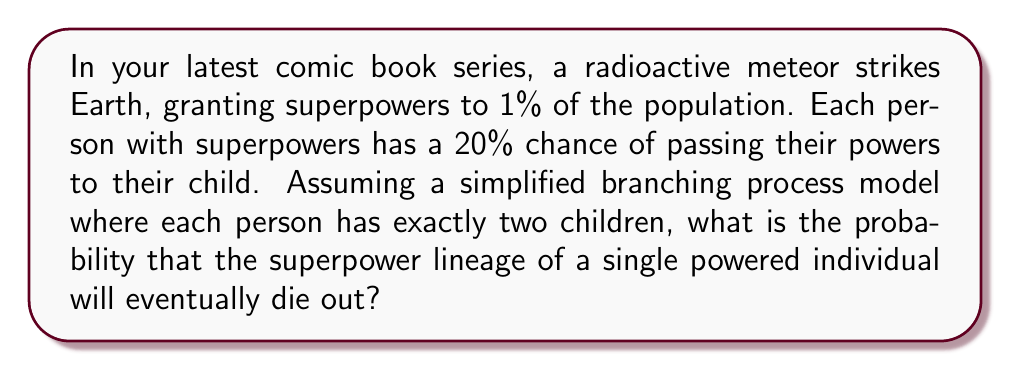Solve this math problem. Let's approach this step-by-step using the theory of branching processes:

1) Let $p_k$ be the probability of a powered individual having $k$ powered children. In this case:
   $p_0 = 0.64$ (probability of neither child inheriting powers)
   $p_1 = 0.32$ (probability of exactly one child inheriting powers)
   $p_2 = 0.04$ (probability of both children inheriting powers)

2) The probability generating function (PGF) for this process is:
   $$G(s) = p_0 + p_1s + p_2s^2 = 0.64 + 0.32s + 0.04s^2$$

3) The extinction probability, $q$, is the smallest non-negative root of the equation $s = G(s)$. So we need to solve:
   $$s = 0.64 + 0.32s + 0.04s^2$$

4) Rearranging the equation:
   $$0.04s^2 + 0.68s - 0.64 = 0$$

5) This is a quadratic equation. We can solve it using the quadratic formula:
   $$s = \frac{-b \pm \sqrt{b^2 - 4ac}}{2a}$$
   where $a = 0.04$, $b = 0.68$, and $c = -0.64$

6) Plugging in these values:
   $$s = \frac{-0.68 \pm \sqrt{0.68^2 - 4(0.04)(-0.64)}}{2(0.04)}$$

7) Simplifying:
   $$s = \frac{-0.68 \pm \sqrt{0.4624 + 0.1024}}{0.08} = \frac{-0.68 \pm \sqrt{0.5648}}{0.08}$$

8) Calculating:
   $$s = \frac{-0.68 \pm 0.7516}{0.08}$$

9) This gives us two solutions:
   $s_1 = 0.8955$ and $s_2 = -9.8955$

10) Since we're looking for a probability, we take the non-negative root less than or equal to 1. Therefore, the extinction probability $q = 0.8955$.
Answer: 0.8955 